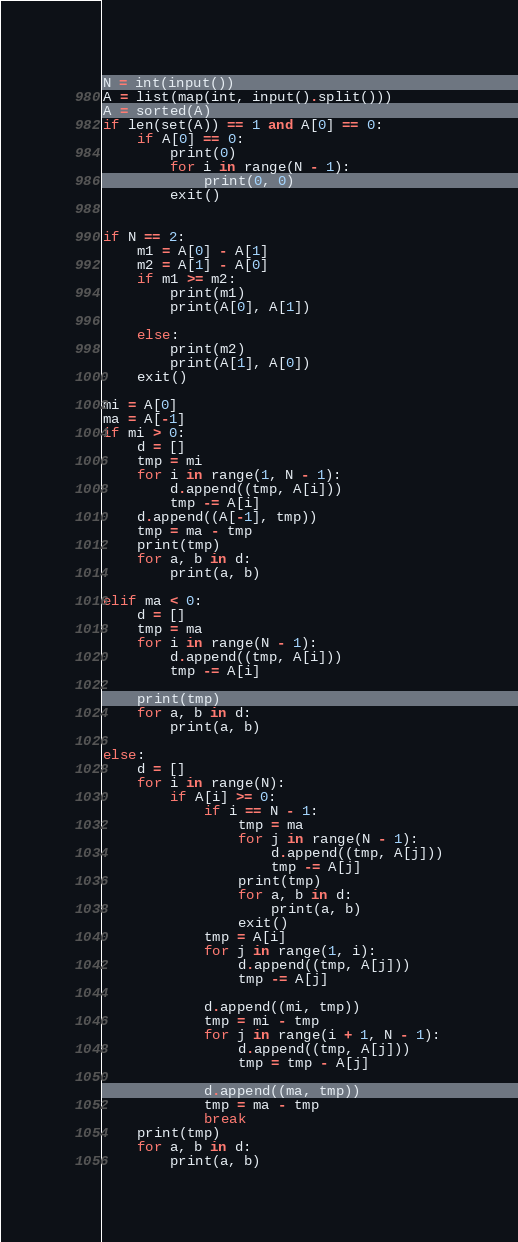Convert code to text. <code><loc_0><loc_0><loc_500><loc_500><_Python_>N = int(input())
A = list(map(int, input().split()))
A = sorted(A)
if len(set(A)) == 1 and A[0] == 0:
    if A[0] == 0:
        print(0)
        for i in range(N - 1):
            print(0, 0)
        exit()


if N == 2:
    m1 = A[0] - A[1]
    m2 = A[1] - A[0]
    if m1 >= m2:
        print(m1)
        print(A[0], A[1])

    else:
        print(m2)
        print(A[1], A[0])
    exit()

mi = A[0]
ma = A[-1]
if mi > 0:
    d = []
    tmp = mi
    for i in range(1, N - 1):
        d.append((tmp, A[i]))
        tmp -= A[i]
    d.append((A[-1], tmp))
    tmp = ma - tmp
    print(tmp)
    for a, b in d:
        print(a, b)

elif ma < 0:
    d = []
    tmp = ma
    for i in range(N - 1):
        d.append((tmp, A[i]))
        tmp -= A[i]

    print(tmp)
    for a, b in d:
        print(a, b)

else:
    d = []
    for i in range(N):
        if A[i] >= 0:
            if i == N - 1:
                tmp = ma
                for j in range(N - 1):
                    d.append((tmp, A[j]))
                    tmp -= A[j]
                print(tmp)
                for a, b in d:
                    print(a, b)
                exit()
            tmp = A[i]
            for j in range(1, i):
                d.append((tmp, A[j]))
                tmp -= A[j]

            d.append((mi, tmp))
            tmp = mi - tmp
            for j in range(i + 1, N - 1):
                d.append((tmp, A[j]))
                tmp = tmp - A[j]

            d.append((ma, tmp))
            tmp = ma - tmp
            break
    print(tmp)
    for a, b in d:
        print(a, b)</code> 